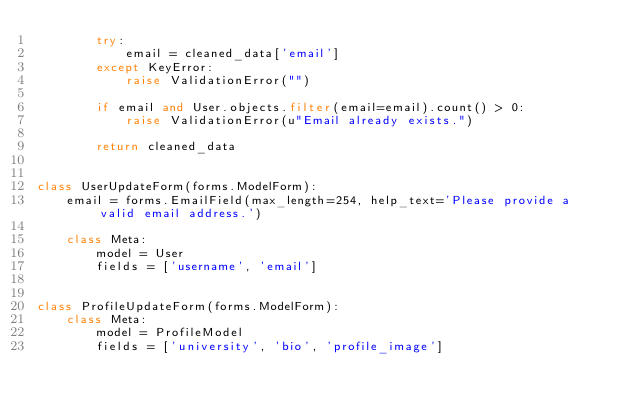<code> <loc_0><loc_0><loc_500><loc_500><_Python_>        try:
            email = cleaned_data['email']
        except KeyError:
            raise ValidationError("")

        if email and User.objects.filter(email=email).count() > 0:
            raise ValidationError(u"Email already exists.")

        return cleaned_data


class UserUpdateForm(forms.ModelForm):
    email = forms.EmailField(max_length=254, help_text='Please provide a valid email address.')

    class Meta:
        model = User
        fields = ['username', 'email']


class ProfileUpdateForm(forms.ModelForm):
    class Meta:
        model = ProfileModel
        fields = ['university', 'bio', 'profile_image']
</code> 